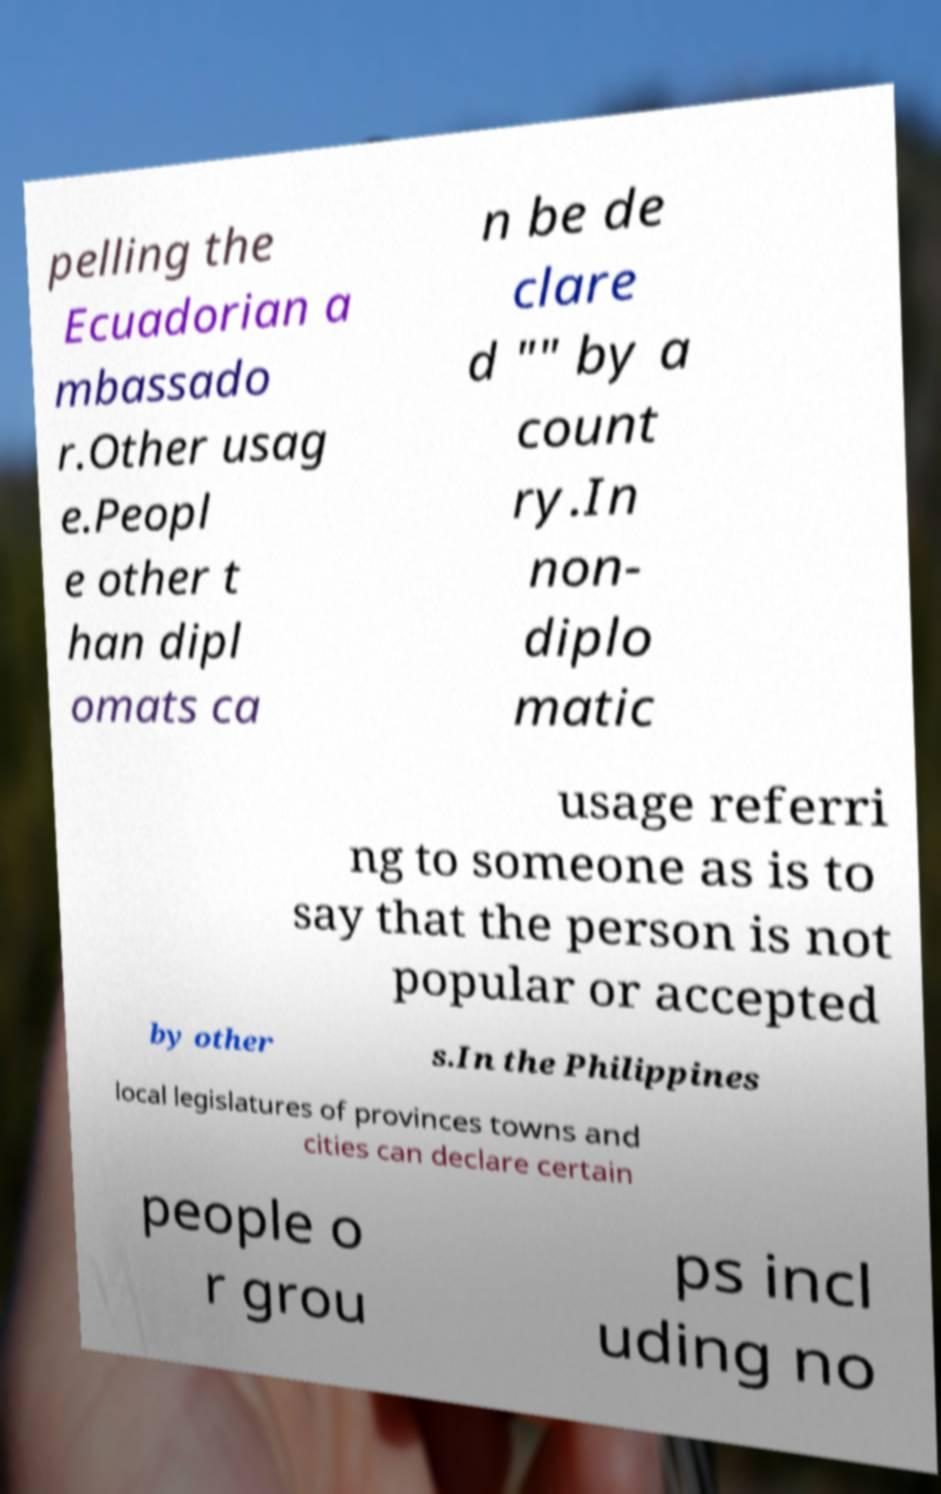Can you accurately transcribe the text from the provided image for me? pelling the Ecuadorian a mbassado r.Other usag e.Peopl e other t han dipl omats ca n be de clare d "" by a count ry.In non- diplo matic usage referri ng to someone as is to say that the person is not popular or accepted by other s.In the Philippines local legislatures of provinces towns and cities can declare certain people o r grou ps incl uding no 